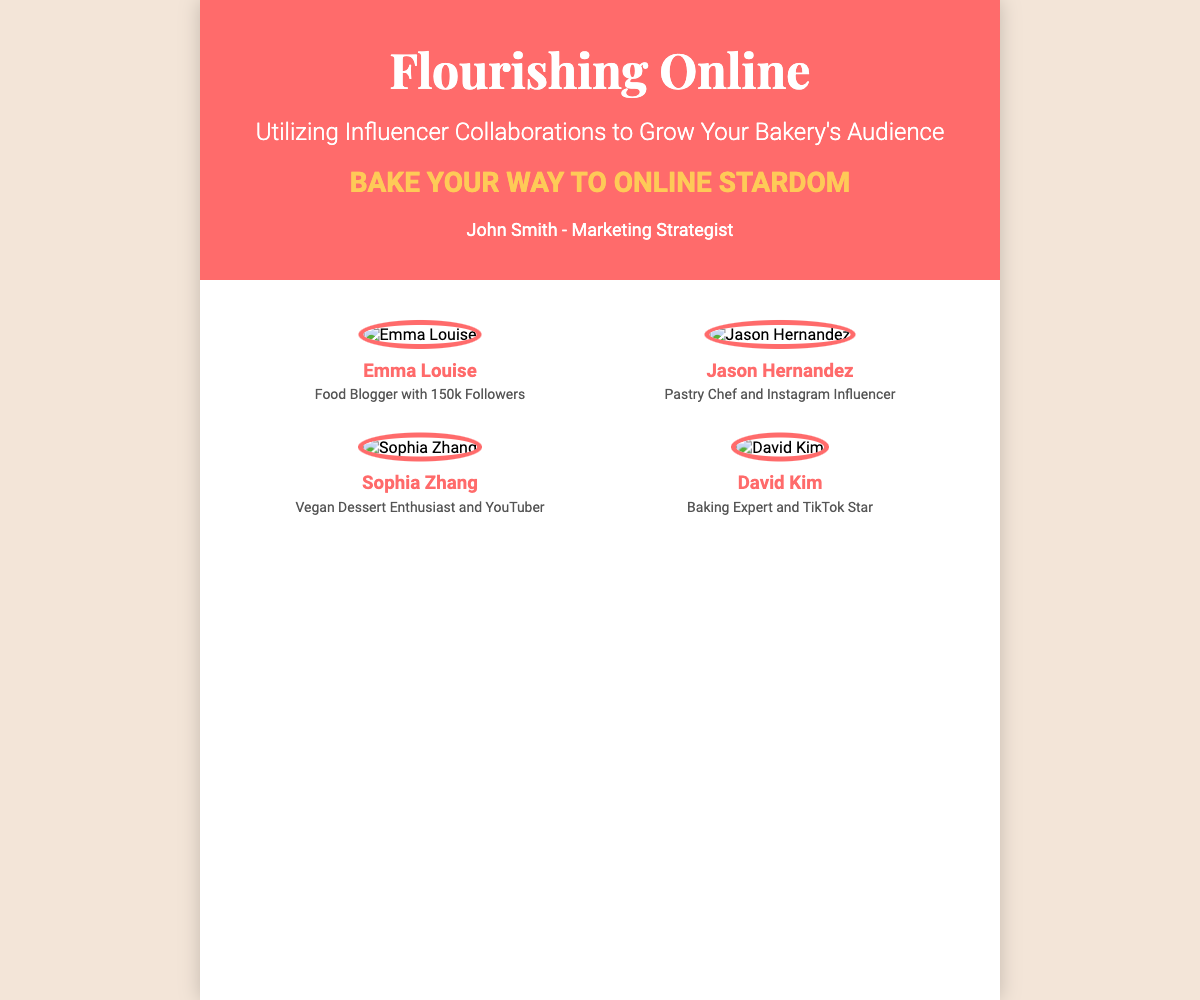What is the title of the book? The title of the book is prominently displayed in the header section of the document.
Answer: Flourishing Online Who is the author of the book? The author name is listed at the bottom of the header section.
Answer: John Smith How many influencers are featured on the cover? There are four influencers provided in the influencers section of the document.
Answer: 4 What is the tagline of the book? The tagline is displayed prominently beneath the book’s title, emphasizing the book's theme.
Answer: Bake Your Way to Online Stardom Which influencer has 150k followers? The follower count is specifically mentioned in the description of the first influencer.
Answer: Emma Louise What social media platform is David Kim known for? David Kim's description specifies his popularity on a specific social media platform.
Answer: TikTok Which influencer is a Vegan Dessert Enthusiast? The description reveals the identity of the influencer with this specialization.
Answer: Sophia Zhang What type of collaboration does the book focus on? The focus of the book is stated in the subtitle, which mentions a specific type of collaboration.
Answer: Influencer Collaborations 